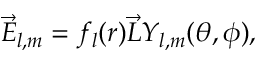Convert formula to latex. <formula><loc_0><loc_0><loc_500><loc_500>\overrightarrow { E } _ { l , m } = f _ { l } ( r ) \overrightarrow { L } Y _ { l , m } ( \theta , \phi ) ,</formula> 